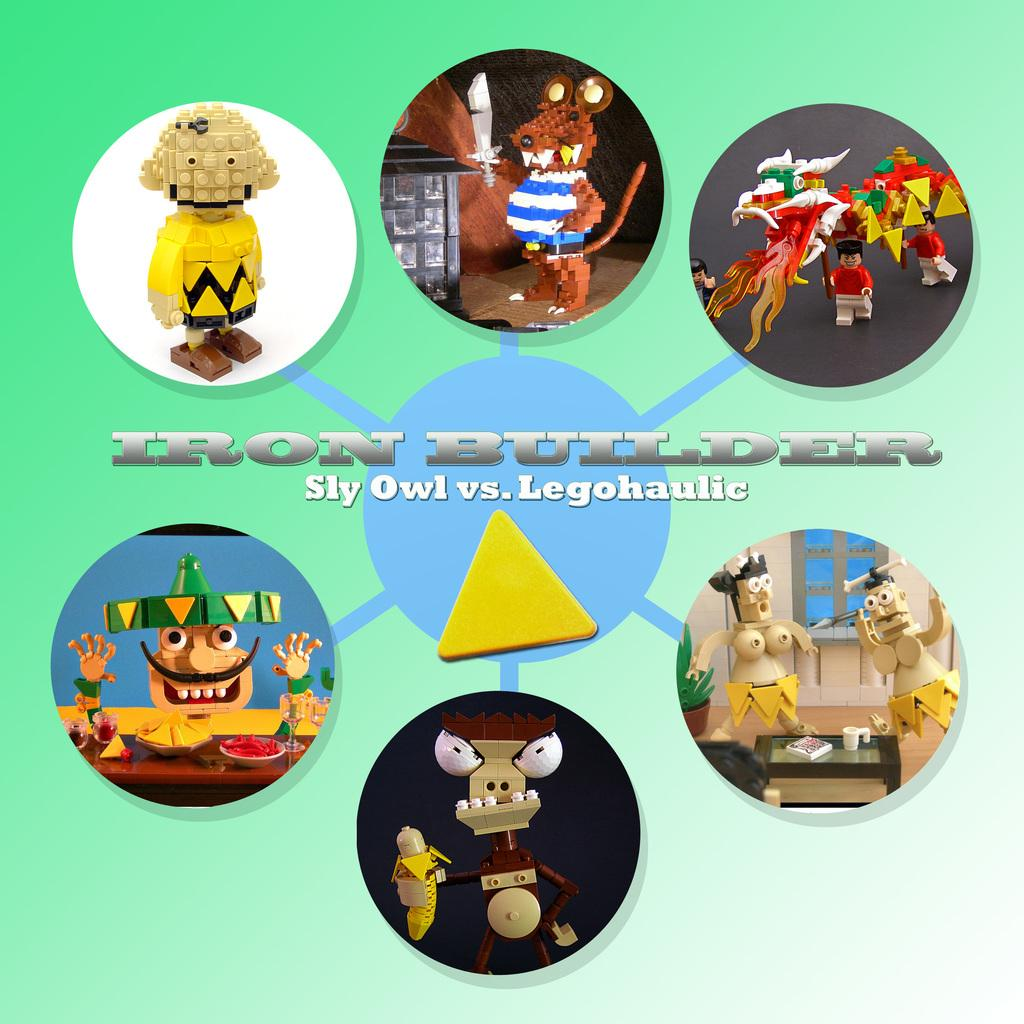What is featured in the picture? There is a poster in the picture. What can be seen on the poster? The poster contains images of toys. Is there any text on the poster? Yes, there is text on the poster. What type of railway can be seen in the picture? There is no railway present in the picture; it only features a poster with images of toys and text. 